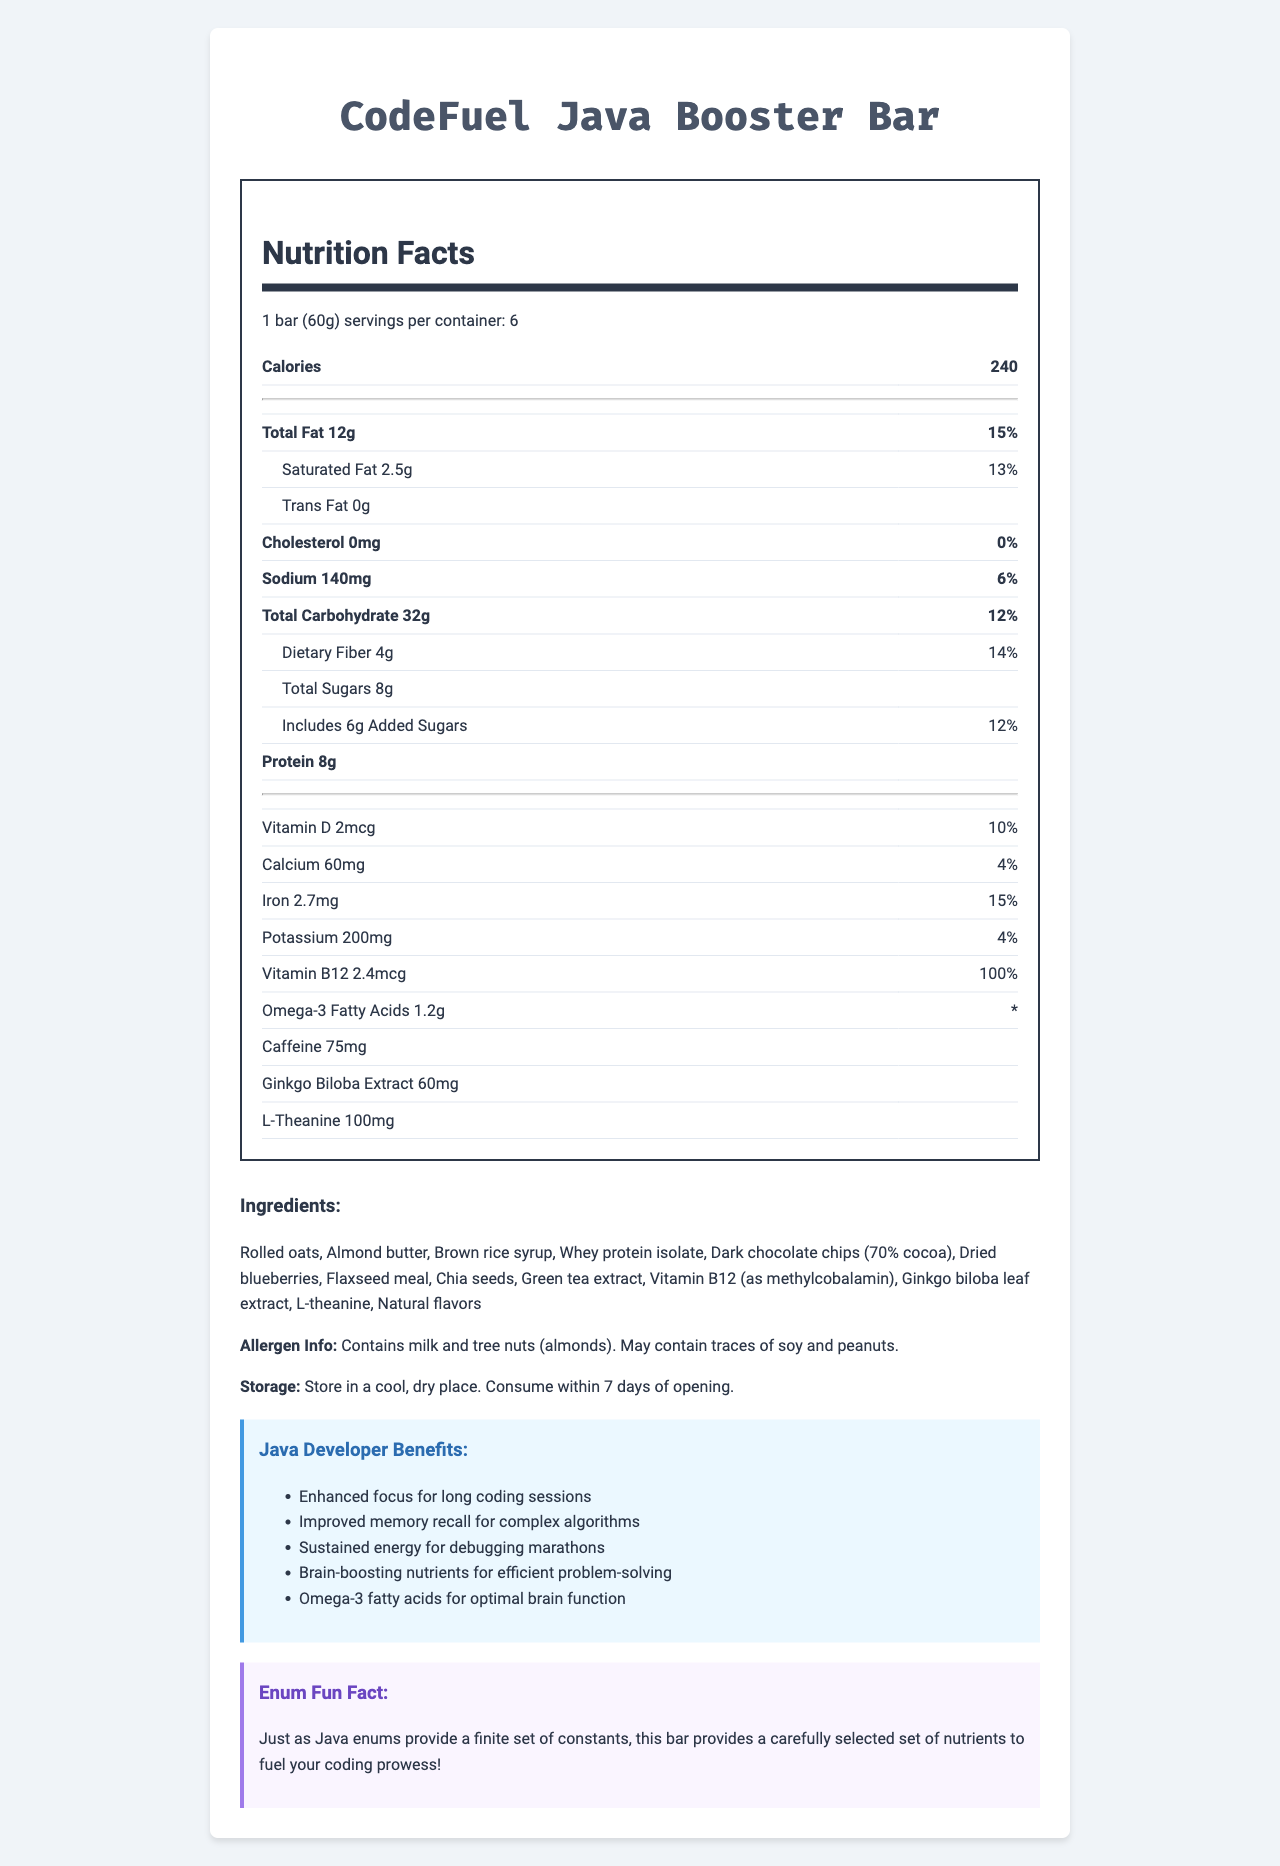what is the serving size of the CodeFuel Java Booster Bar? The serving size is specifically listed in the nutrition facts section at the top of the document.
Answer: 1 bar (60g) how many calories are there in one serving of the CodeFuel Java Booster Bar? The number of calories per serving is displayed prominently under the nutrition facts section.
Answer: 240 what is the total fat content per serving? The total fat content is listed under the nutrition facts section as 12g.
Answer: 12g how much protein does one bar contain? The protein content is displayed in the nutrition facts table as 8g.
Answer: 8g what are two ingredients in the bar that are known for their brain-boosting properties? These ingredients are listed in the ingredients section and are highlighted as brain-boosting nutrients.
Answer: Ginkgo biloba leaf extract and L-theanine which of the following ingredients is not listed in the document? A. Flaxseed meal B. Chia seeds C. Coconut oil D. Almond butter Coconut oil is not listed in the provided ingredients, whereas the other options are.
Answer: C. Coconut oil which vitamin has the highest daily value percentage in this product? A. Vitamin D B. Vitamin B12 C. Calcium D. Iron Vitamin B12 has the highest daily value percentage at 100%.
Answer: B. Vitamin B12 which statement is true about the sugars in the CodeFuel Java Booster Bar? A. There are 8g of total sugars. B. There are no added sugars. C. There are 6g of added sugars. D. Both A and C The nutrition facts indicate there are 8g of total sugars and 6g of added sugars, making both A and C correct.
Answer: D. Both A and C does the CodeFuel Java Booster Bar contain caffeine? Caffeine is listed as one of the ingredients with 75mg.
Answer: Yes what is one benefit of this bar for Java developers according to the document? This is specifically listed as one of the benefits for Java developers.
Answer: Enhanced focus for long coding sessions what allergens does this product contain? The allergen information specifies milk and tree nuts (almonds) and also mentions that it may contain traces of soy and peanuts.
Answer: Milk and tree nuts (almonds) how should the CodeFuel Java Booster Bar be stored? The storage instructions specify how to store the product and that it should be consumed within 7 days of opening.
Answer: In a cool, dry place; consume within 7 days of opening describe the main idea of the document. The document includes the nutritional content, ingredient list, allergen information, developer benefits, and storage instructions for the CodeFuel Java Booster Bar, supported by some fun facts aimed at Java developers.
Answer: The document provides detailed nutrition information and benefits of the CodeFuel Java Booster Bar for Java developers, highlighting its brain-boosting ingredients and allergen information. what is the exact percentage of the daily value for vitamin D in one bar? The percentage of the daily value for vitamin D is clearly listed as 10% in the nutrition facts.
Answer: 10% what is the fun fact related to Java enums mentioned in the document? This fun fact is highlighted at the end of the document and relates nutrients to finite constants in Java enums.
Answer: Just as Java enums provide a finite set of constants, this bar provides a carefully selected set of nutrients to fuel your coding prowess! how much omega-3 fatty acids are present in one bar? The amount of omega-3 fatty acids is listed in the nutrition facts as 1.2g.
Answer: 1.2g does the CodeFuel Java Booster Bar contain soy? The allergen information indicates that it may contain traces of soy, but it’s not definitive whether it contains soy.
Answer: Not enough information 